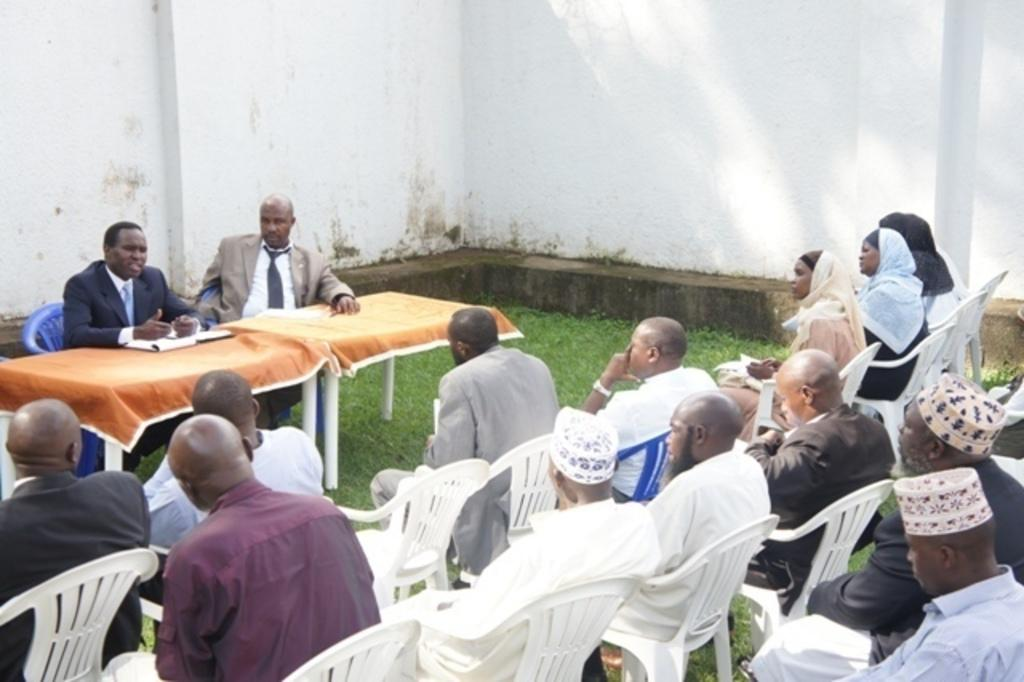Who are the two people in the center of the image? The facts do not specify the identities of the two people in the center. What are the people in the image doing? The two people in the center are sitting, and many people are sitting and listening to them. What can be seen on the tables in the image? Papers are placed on the tables. What might the people be using the tables for? The tables might be used for holding papers or other materials related to the activity in which the people are engaged. What type of knife is being used by the ghost in the image? There is no knife or ghost present in the image. 